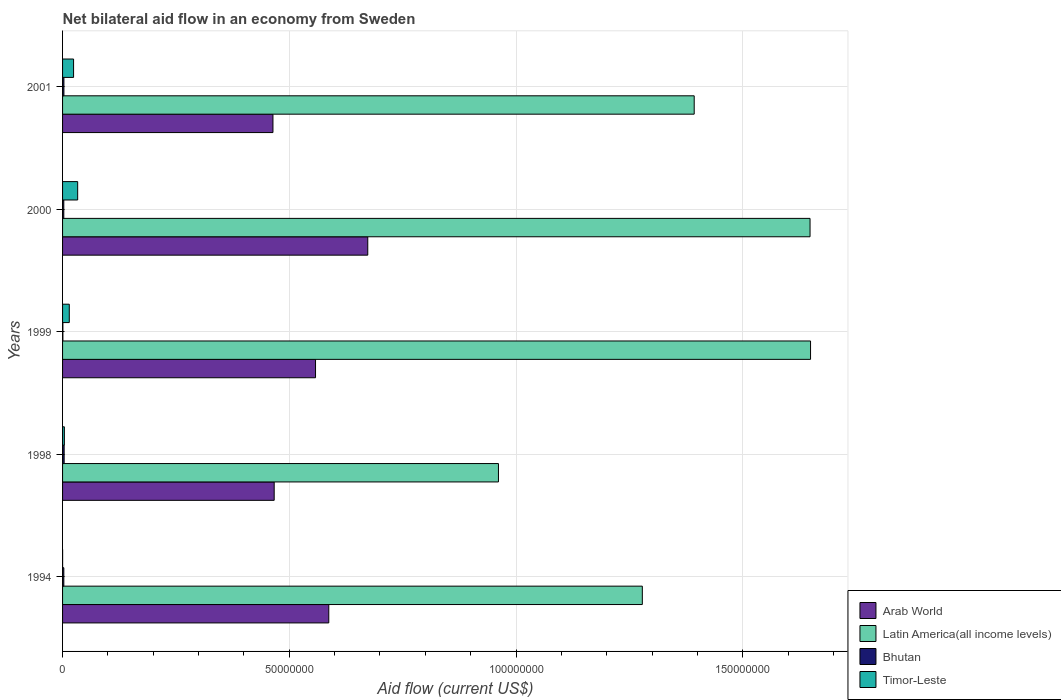How many different coloured bars are there?
Ensure brevity in your answer.  4. Are the number of bars on each tick of the Y-axis equal?
Make the answer very short. Yes. How many bars are there on the 1st tick from the bottom?
Provide a succinct answer. 4. What is the label of the 3rd group of bars from the top?
Your answer should be very brief. 1999. In how many cases, is the number of bars for a given year not equal to the number of legend labels?
Your response must be concise. 0. What is the net bilateral aid flow in Latin America(all income levels) in 1998?
Your response must be concise. 9.61e+07. Across all years, what is the maximum net bilateral aid flow in Latin America(all income levels)?
Ensure brevity in your answer.  1.65e+08. Across all years, what is the minimum net bilateral aid flow in Bhutan?
Offer a terse response. 7.00e+04. What is the total net bilateral aid flow in Timor-Leste in the graph?
Provide a succinct answer. 7.65e+06. What is the difference between the net bilateral aid flow in Bhutan in 1994 and that in 2001?
Provide a short and direct response. -2.00e+04. What is the difference between the net bilateral aid flow in Arab World in 1999 and the net bilateral aid flow in Timor-Leste in 2001?
Provide a succinct answer. 5.34e+07. What is the average net bilateral aid flow in Latin America(all income levels) per year?
Offer a terse response. 1.39e+08. In the year 1999, what is the difference between the net bilateral aid flow in Arab World and net bilateral aid flow in Bhutan?
Keep it short and to the point. 5.57e+07. In how many years, is the net bilateral aid flow in Bhutan greater than 10000000 US$?
Make the answer very short. 0. What is the ratio of the net bilateral aid flow in Latin America(all income levels) in 1994 to that in 1998?
Offer a very short reply. 1.33. Is the net bilateral aid flow in Arab World in 1994 less than that in 2000?
Your answer should be compact. Yes. Is the difference between the net bilateral aid flow in Arab World in 1998 and 2000 greater than the difference between the net bilateral aid flow in Bhutan in 1998 and 2000?
Offer a terse response. No. What is the difference between the highest and the lowest net bilateral aid flow in Latin America(all income levels)?
Ensure brevity in your answer.  6.88e+07. In how many years, is the net bilateral aid flow in Latin America(all income levels) greater than the average net bilateral aid flow in Latin America(all income levels) taken over all years?
Keep it short and to the point. 3. Is the sum of the net bilateral aid flow in Bhutan in 1999 and 2000 greater than the maximum net bilateral aid flow in Arab World across all years?
Provide a succinct answer. No. Is it the case that in every year, the sum of the net bilateral aid flow in Arab World and net bilateral aid flow in Latin America(all income levels) is greater than the sum of net bilateral aid flow in Timor-Leste and net bilateral aid flow in Bhutan?
Give a very brief answer. Yes. What does the 4th bar from the top in 1994 represents?
Offer a terse response. Arab World. What does the 3rd bar from the bottom in 2000 represents?
Provide a short and direct response. Bhutan. Is it the case that in every year, the sum of the net bilateral aid flow in Timor-Leste and net bilateral aid flow in Bhutan is greater than the net bilateral aid flow in Latin America(all income levels)?
Provide a short and direct response. No. How many bars are there?
Provide a short and direct response. 20. What is the difference between two consecutive major ticks on the X-axis?
Give a very brief answer. 5.00e+07. Are the values on the major ticks of X-axis written in scientific E-notation?
Your response must be concise. No. Does the graph contain any zero values?
Give a very brief answer. No. Does the graph contain grids?
Your answer should be very brief. Yes. How many legend labels are there?
Ensure brevity in your answer.  4. What is the title of the graph?
Your answer should be compact. Net bilateral aid flow in an economy from Sweden. Does "Sweden" appear as one of the legend labels in the graph?
Ensure brevity in your answer.  No. What is the label or title of the X-axis?
Provide a succinct answer. Aid flow (current US$). What is the label or title of the Y-axis?
Offer a very short reply. Years. What is the Aid flow (current US$) in Arab World in 1994?
Your answer should be compact. 5.87e+07. What is the Aid flow (current US$) of Latin America(all income levels) in 1994?
Make the answer very short. 1.28e+08. What is the Aid flow (current US$) in Bhutan in 1994?
Your answer should be very brief. 2.80e+05. What is the Aid flow (current US$) in Arab World in 1998?
Offer a very short reply. 4.67e+07. What is the Aid flow (current US$) in Latin America(all income levels) in 1998?
Make the answer very short. 9.61e+07. What is the Aid flow (current US$) in Timor-Leste in 1998?
Give a very brief answer. 4.00e+05. What is the Aid flow (current US$) in Arab World in 1999?
Give a very brief answer. 5.58e+07. What is the Aid flow (current US$) in Latin America(all income levels) in 1999?
Offer a terse response. 1.65e+08. What is the Aid flow (current US$) of Timor-Leste in 1999?
Your answer should be very brief. 1.48e+06. What is the Aid flow (current US$) in Arab World in 2000?
Keep it short and to the point. 6.73e+07. What is the Aid flow (current US$) of Latin America(all income levels) in 2000?
Your response must be concise. 1.65e+08. What is the Aid flow (current US$) in Timor-Leste in 2000?
Ensure brevity in your answer.  3.33e+06. What is the Aid flow (current US$) in Arab World in 2001?
Provide a succinct answer. 4.64e+07. What is the Aid flow (current US$) of Latin America(all income levels) in 2001?
Offer a very short reply. 1.39e+08. What is the Aid flow (current US$) in Timor-Leste in 2001?
Keep it short and to the point. 2.43e+06. Across all years, what is the maximum Aid flow (current US$) of Arab World?
Your answer should be very brief. 6.73e+07. Across all years, what is the maximum Aid flow (current US$) of Latin America(all income levels)?
Your answer should be compact. 1.65e+08. Across all years, what is the maximum Aid flow (current US$) of Timor-Leste?
Offer a very short reply. 3.33e+06. Across all years, what is the minimum Aid flow (current US$) in Arab World?
Make the answer very short. 4.64e+07. Across all years, what is the minimum Aid flow (current US$) in Latin America(all income levels)?
Provide a short and direct response. 9.61e+07. Across all years, what is the minimum Aid flow (current US$) in Timor-Leste?
Offer a terse response. 10000. What is the total Aid flow (current US$) in Arab World in the graph?
Provide a succinct answer. 2.75e+08. What is the total Aid flow (current US$) of Latin America(all income levels) in the graph?
Offer a terse response. 6.93e+08. What is the total Aid flow (current US$) of Bhutan in the graph?
Your answer should be compact. 1.27e+06. What is the total Aid flow (current US$) in Timor-Leste in the graph?
Ensure brevity in your answer.  7.65e+06. What is the difference between the Aid flow (current US$) in Arab World in 1994 and that in 1998?
Provide a succinct answer. 1.20e+07. What is the difference between the Aid flow (current US$) in Latin America(all income levels) in 1994 and that in 1998?
Provide a short and direct response. 3.17e+07. What is the difference between the Aid flow (current US$) in Timor-Leste in 1994 and that in 1998?
Provide a succinct answer. -3.90e+05. What is the difference between the Aid flow (current US$) in Arab World in 1994 and that in 1999?
Provide a short and direct response. 2.92e+06. What is the difference between the Aid flow (current US$) in Latin America(all income levels) in 1994 and that in 1999?
Keep it short and to the point. -3.71e+07. What is the difference between the Aid flow (current US$) in Bhutan in 1994 and that in 1999?
Provide a succinct answer. 2.10e+05. What is the difference between the Aid flow (current US$) of Timor-Leste in 1994 and that in 1999?
Offer a terse response. -1.47e+06. What is the difference between the Aid flow (current US$) in Arab World in 1994 and that in 2000?
Your answer should be compact. -8.60e+06. What is the difference between the Aid flow (current US$) of Latin America(all income levels) in 1994 and that in 2000?
Ensure brevity in your answer.  -3.70e+07. What is the difference between the Aid flow (current US$) of Bhutan in 1994 and that in 2000?
Offer a terse response. 10000. What is the difference between the Aid flow (current US$) in Timor-Leste in 1994 and that in 2000?
Keep it short and to the point. -3.32e+06. What is the difference between the Aid flow (current US$) in Arab World in 1994 and that in 2001?
Your answer should be compact. 1.23e+07. What is the difference between the Aid flow (current US$) in Latin America(all income levels) in 1994 and that in 2001?
Keep it short and to the point. -1.14e+07. What is the difference between the Aid flow (current US$) of Bhutan in 1994 and that in 2001?
Provide a succinct answer. -2.00e+04. What is the difference between the Aid flow (current US$) in Timor-Leste in 1994 and that in 2001?
Make the answer very short. -2.42e+06. What is the difference between the Aid flow (current US$) of Arab World in 1998 and that in 1999?
Ensure brevity in your answer.  -9.12e+06. What is the difference between the Aid flow (current US$) in Latin America(all income levels) in 1998 and that in 1999?
Ensure brevity in your answer.  -6.88e+07. What is the difference between the Aid flow (current US$) in Timor-Leste in 1998 and that in 1999?
Offer a very short reply. -1.08e+06. What is the difference between the Aid flow (current US$) of Arab World in 1998 and that in 2000?
Give a very brief answer. -2.06e+07. What is the difference between the Aid flow (current US$) of Latin America(all income levels) in 1998 and that in 2000?
Keep it short and to the point. -6.87e+07. What is the difference between the Aid flow (current US$) in Timor-Leste in 1998 and that in 2000?
Make the answer very short. -2.93e+06. What is the difference between the Aid flow (current US$) of Latin America(all income levels) in 1998 and that in 2001?
Offer a terse response. -4.32e+07. What is the difference between the Aid flow (current US$) in Timor-Leste in 1998 and that in 2001?
Offer a terse response. -2.03e+06. What is the difference between the Aid flow (current US$) in Arab World in 1999 and that in 2000?
Your response must be concise. -1.15e+07. What is the difference between the Aid flow (current US$) in Timor-Leste in 1999 and that in 2000?
Make the answer very short. -1.85e+06. What is the difference between the Aid flow (current US$) of Arab World in 1999 and that in 2001?
Offer a terse response. 9.39e+06. What is the difference between the Aid flow (current US$) of Latin America(all income levels) in 1999 and that in 2001?
Your response must be concise. 2.57e+07. What is the difference between the Aid flow (current US$) of Bhutan in 1999 and that in 2001?
Ensure brevity in your answer.  -2.30e+05. What is the difference between the Aid flow (current US$) of Timor-Leste in 1999 and that in 2001?
Your answer should be very brief. -9.50e+05. What is the difference between the Aid flow (current US$) in Arab World in 2000 and that in 2001?
Offer a terse response. 2.09e+07. What is the difference between the Aid flow (current US$) of Latin America(all income levels) in 2000 and that in 2001?
Your answer should be compact. 2.56e+07. What is the difference between the Aid flow (current US$) in Timor-Leste in 2000 and that in 2001?
Provide a succinct answer. 9.00e+05. What is the difference between the Aid flow (current US$) of Arab World in 1994 and the Aid flow (current US$) of Latin America(all income levels) in 1998?
Ensure brevity in your answer.  -3.74e+07. What is the difference between the Aid flow (current US$) in Arab World in 1994 and the Aid flow (current US$) in Bhutan in 1998?
Make the answer very short. 5.84e+07. What is the difference between the Aid flow (current US$) in Arab World in 1994 and the Aid flow (current US$) in Timor-Leste in 1998?
Your answer should be very brief. 5.83e+07. What is the difference between the Aid flow (current US$) in Latin America(all income levels) in 1994 and the Aid flow (current US$) in Bhutan in 1998?
Your response must be concise. 1.28e+08. What is the difference between the Aid flow (current US$) of Latin America(all income levels) in 1994 and the Aid flow (current US$) of Timor-Leste in 1998?
Offer a terse response. 1.27e+08. What is the difference between the Aid flow (current US$) of Arab World in 1994 and the Aid flow (current US$) of Latin America(all income levels) in 1999?
Make the answer very short. -1.06e+08. What is the difference between the Aid flow (current US$) in Arab World in 1994 and the Aid flow (current US$) in Bhutan in 1999?
Offer a terse response. 5.86e+07. What is the difference between the Aid flow (current US$) of Arab World in 1994 and the Aid flow (current US$) of Timor-Leste in 1999?
Provide a short and direct response. 5.72e+07. What is the difference between the Aid flow (current US$) in Latin America(all income levels) in 1994 and the Aid flow (current US$) in Bhutan in 1999?
Your answer should be compact. 1.28e+08. What is the difference between the Aid flow (current US$) of Latin America(all income levels) in 1994 and the Aid flow (current US$) of Timor-Leste in 1999?
Offer a terse response. 1.26e+08. What is the difference between the Aid flow (current US$) of Bhutan in 1994 and the Aid flow (current US$) of Timor-Leste in 1999?
Ensure brevity in your answer.  -1.20e+06. What is the difference between the Aid flow (current US$) in Arab World in 1994 and the Aid flow (current US$) in Latin America(all income levels) in 2000?
Offer a terse response. -1.06e+08. What is the difference between the Aid flow (current US$) of Arab World in 1994 and the Aid flow (current US$) of Bhutan in 2000?
Give a very brief answer. 5.84e+07. What is the difference between the Aid flow (current US$) of Arab World in 1994 and the Aid flow (current US$) of Timor-Leste in 2000?
Provide a succinct answer. 5.54e+07. What is the difference between the Aid flow (current US$) in Latin America(all income levels) in 1994 and the Aid flow (current US$) in Bhutan in 2000?
Ensure brevity in your answer.  1.28e+08. What is the difference between the Aid flow (current US$) in Latin America(all income levels) in 1994 and the Aid flow (current US$) in Timor-Leste in 2000?
Provide a short and direct response. 1.25e+08. What is the difference between the Aid flow (current US$) of Bhutan in 1994 and the Aid flow (current US$) of Timor-Leste in 2000?
Keep it short and to the point. -3.05e+06. What is the difference between the Aid flow (current US$) in Arab World in 1994 and the Aid flow (current US$) in Latin America(all income levels) in 2001?
Your response must be concise. -8.06e+07. What is the difference between the Aid flow (current US$) of Arab World in 1994 and the Aid flow (current US$) of Bhutan in 2001?
Give a very brief answer. 5.84e+07. What is the difference between the Aid flow (current US$) in Arab World in 1994 and the Aid flow (current US$) in Timor-Leste in 2001?
Provide a short and direct response. 5.63e+07. What is the difference between the Aid flow (current US$) of Latin America(all income levels) in 1994 and the Aid flow (current US$) of Bhutan in 2001?
Offer a terse response. 1.28e+08. What is the difference between the Aid flow (current US$) in Latin America(all income levels) in 1994 and the Aid flow (current US$) in Timor-Leste in 2001?
Offer a very short reply. 1.25e+08. What is the difference between the Aid flow (current US$) of Bhutan in 1994 and the Aid flow (current US$) of Timor-Leste in 2001?
Provide a short and direct response. -2.15e+06. What is the difference between the Aid flow (current US$) of Arab World in 1998 and the Aid flow (current US$) of Latin America(all income levels) in 1999?
Offer a terse response. -1.18e+08. What is the difference between the Aid flow (current US$) of Arab World in 1998 and the Aid flow (current US$) of Bhutan in 1999?
Your response must be concise. 4.66e+07. What is the difference between the Aid flow (current US$) of Arab World in 1998 and the Aid flow (current US$) of Timor-Leste in 1999?
Your answer should be compact. 4.52e+07. What is the difference between the Aid flow (current US$) of Latin America(all income levels) in 1998 and the Aid flow (current US$) of Bhutan in 1999?
Offer a very short reply. 9.61e+07. What is the difference between the Aid flow (current US$) of Latin America(all income levels) in 1998 and the Aid flow (current US$) of Timor-Leste in 1999?
Keep it short and to the point. 9.46e+07. What is the difference between the Aid flow (current US$) of Bhutan in 1998 and the Aid flow (current US$) of Timor-Leste in 1999?
Offer a terse response. -1.13e+06. What is the difference between the Aid flow (current US$) of Arab World in 1998 and the Aid flow (current US$) of Latin America(all income levels) in 2000?
Give a very brief answer. -1.18e+08. What is the difference between the Aid flow (current US$) of Arab World in 1998 and the Aid flow (current US$) of Bhutan in 2000?
Give a very brief answer. 4.64e+07. What is the difference between the Aid flow (current US$) of Arab World in 1998 and the Aid flow (current US$) of Timor-Leste in 2000?
Your answer should be very brief. 4.33e+07. What is the difference between the Aid flow (current US$) in Latin America(all income levels) in 1998 and the Aid flow (current US$) in Bhutan in 2000?
Offer a terse response. 9.59e+07. What is the difference between the Aid flow (current US$) in Latin America(all income levels) in 1998 and the Aid flow (current US$) in Timor-Leste in 2000?
Offer a very short reply. 9.28e+07. What is the difference between the Aid flow (current US$) in Bhutan in 1998 and the Aid flow (current US$) in Timor-Leste in 2000?
Offer a terse response. -2.98e+06. What is the difference between the Aid flow (current US$) of Arab World in 1998 and the Aid flow (current US$) of Latin America(all income levels) in 2001?
Make the answer very short. -9.26e+07. What is the difference between the Aid flow (current US$) in Arab World in 1998 and the Aid flow (current US$) in Bhutan in 2001?
Give a very brief answer. 4.64e+07. What is the difference between the Aid flow (current US$) in Arab World in 1998 and the Aid flow (current US$) in Timor-Leste in 2001?
Offer a terse response. 4.42e+07. What is the difference between the Aid flow (current US$) of Latin America(all income levels) in 1998 and the Aid flow (current US$) of Bhutan in 2001?
Your response must be concise. 9.58e+07. What is the difference between the Aid flow (current US$) of Latin America(all income levels) in 1998 and the Aid flow (current US$) of Timor-Leste in 2001?
Give a very brief answer. 9.37e+07. What is the difference between the Aid flow (current US$) in Bhutan in 1998 and the Aid flow (current US$) in Timor-Leste in 2001?
Provide a short and direct response. -2.08e+06. What is the difference between the Aid flow (current US$) in Arab World in 1999 and the Aid flow (current US$) in Latin America(all income levels) in 2000?
Give a very brief answer. -1.09e+08. What is the difference between the Aid flow (current US$) in Arab World in 1999 and the Aid flow (current US$) in Bhutan in 2000?
Make the answer very short. 5.55e+07. What is the difference between the Aid flow (current US$) of Arab World in 1999 and the Aid flow (current US$) of Timor-Leste in 2000?
Your answer should be compact. 5.25e+07. What is the difference between the Aid flow (current US$) in Latin America(all income levels) in 1999 and the Aid flow (current US$) in Bhutan in 2000?
Make the answer very short. 1.65e+08. What is the difference between the Aid flow (current US$) of Latin America(all income levels) in 1999 and the Aid flow (current US$) of Timor-Leste in 2000?
Offer a terse response. 1.62e+08. What is the difference between the Aid flow (current US$) of Bhutan in 1999 and the Aid flow (current US$) of Timor-Leste in 2000?
Provide a succinct answer. -3.26e+06. What is the difference between the Aid flow (current US$) in Arab World in 1999 and the Aid flow (current US$) in Latin America(all income levels) in 2001?
Give a very brief answer. -8.35e+07. What is the difference between the Aid flow (current US$) in Arab World in 1999 and the Aid flow (current US$) in Bhutan in 2001?
Ensure brevity in your answer.  5.55e+07. What is the difference between the Aid flow (current US$) of Arab World in 1999 and the Aid flow (current US$) of Timor-Leste in 2001?
Offer a terse response. 5.34e+07. What is the difference between the Aid flow (current US$) of Latin America(all income levels) in 1999 and the Aid flow (current US$) of Bhutan in 2001?
Your answer should be compact. 1.65e+08. What is the difference between the Aid flow (current US$) of Latin America(all income levels) in 1999 and the Aid flow (current US$) of Timor-Leste in 2001?
Provide a short and direct response. 1.63e+08. What is the difference between the Aid flow (current US$) of Bhutan in 1999 and the Aid flow (current US$) of Timor-Leste in 2001?
Give a very brief answer. -2.36e+06. What is the difference between the Aid flow (current US$) of Arab World in 2000 and the Aid flow (current US$) of Latin America(all income levels) in 2001?
Provide a short and direct response. -7.20e+07. What is the difference between the Aid flow (current US$) of Arab World in 2000 and the Aid flow (current US$) of Bhutan in 2001?
Your answer should be very brief. 6.70e+07. What is the difference between the Aid flow (current US$) of Arab World in 2000 and the Aid flow (current US$) of Timor-Leste in 2001?
Provide a short and direct response. 6.49e+07. What is the difference between the Aid flow (current US$) in Latin America(all income levels) in 2000 and the Aid flow (current US$) in Bhutan in 2001?
Offer a terse response. 1.65e+08. What is the difference between the Aid flow (current US$) in Latin America(all income levels) in 2000 and the Aid flow (current US$) in Timor-Leste in 2001?
Give a very brief answer. 1.62e+08. What is the difference between the Aid flow (current US$) in Bhutan in 2000 and the Aid flow (current US$) in Timor-Leste in 2001?
Make the answer very short. -2.16e+06. What is the average Aid flow (current US$) of Arab World per year?
Your answer should be very brief. 5.50e+07. What is the average Aid flow (current US$) in Latin America(all income levels) per year?
Your answer should be compact. 1.39e+08. What is the average Aid flow (current US$) of Bhutan per year?
Give a very brief answer. 2.54e+05. What is the average Aid flow (current US$) in Timor-Leste per year?
Your answer should be very brief. 1.53e+06. In the year 1994, what is the difference between the Aid flow (current US$) of Arab World and Aid flow (current US$) of Latin America(all income levels)?
Keep it short and to the point. -6.92e+07. In the year 1994, what is the difference between the Aid flow (current US$) in Arab World and Aid flow (current US$) in Bhutan?
Offer a terse response. 5.84e+07. In the year 1994, what is the difference between the Aid flow (current US$) of Arab World and Aid flow (current US$) of Timor-Leste?
Provide a short and direct response. 5.87e+07. In the year 1994, what is the difference between the Aid flow (current US$) of Latin America(all income levels) and Aid flow (current US$) of Bhutan?
Your answer should be compact. 1.28e+08. In the year 1994, what is the difference between the Aid flow (current US$) of Latin America(all income levels) and Aid flow (current US$) of Timor-Leste?
Provide a short and direct response. 1.28e+08. In the year 1998, what is the difference between the Aid flow (current US$) in Arab World and Aid flow (current US$) in Latin America(all income levels)?
Provide a succinct answer. -4.95e+07. In the year 1998, what is the difference between the Aid flow (current US$) of Arab World and Aid flow (current US$) of Bhutan?
Offer a very short reply. 4.63e+07. In the year 1998, what is the difference between the Aid flow (current US$) in Arab World and Aid flow (current US$) in Timor-Leste?
Your answer should be very brief. 4.63e+07. In the year 1998, what is the difference between the Aid flow (current US$) in Latin America(all income levels) and Aid flow (current US$) in Bhutan?
Keep it short and to the point. 9.58e+07. In the year 1998, what is the difference between the Aid flow (current US$) in Latin America(all income levels) and Aid flow (current US$) in Timor-Leste?
Provide a succinct answer. 9.57e+07. In the year 1998, what is the difference between the Aid flow (current US$) in Bhutan and Aid flow (current US$) in Timor-Leste?
Provide a short and direct response. -5.00e+04. In the year 1999, what is the difference between the Aid flow (current US$) of Arab World and Aid flow (current US$) of Latin America(all income levels)?
Offer a terse response. -1.09e+08. In the year 1999, what is the difference between the Aid flow (current US$) in Arab World and Aid flow (current US$) in Bhutan?
Ensure brevity in your answer.  5.57e+07. In the year 1999, what is the difference between the Aid flow (current US$) of Arab World and Aid flow (current US$) of Timor-Leste?
Offer a terse response. 5.43e+07. In the year 1999, what is the difference between the Aid flow (current US$) in Latin America(all income levels) and Aid flow (current US$) in Bhutan?
Ensure brevity in your answer.  1.65e+08. In the year 1999, what is the difference between the Aid flow (current US$) of Latin America(all income levels) and Aid flow (current US$) of Timor-Leste?
Your answer should be very brief. 1.63e+08. In the year 1999, what is the difference between the Aid flow (current US$) of Bhutan and Aid flow (current US$) of Timor-Leste?
Your response must be concise. -1.41e+06. In the year 2000, what is the difference between the Aid flow (current US$) in Arab World and Aid flow (current US$) in Latin America(all income levels)?
Offer a very short reply. -9.75e+07. In the year 2000, what is the difference between the Aid flow (current US$) in Arab World and Aid flow (current US$) in Bhutan?
Make the answer very short. 6.70e+07. In the year 2000, what is the difference between the Aid flow (current US$) of Arab World and Aid flow (current US$) of Timor-Leste?
Your answer should be compact. 6.40e+07. In the year 2000, what is the difference between the Aid flow (current US$) in Latin America(all income levels) and Aid flow (current US$) in Bhutan?
Your answer should be compact. 1.65e+08. In the year 2000, what is the difference between the Aid flow (current US$) in Latin America(all income levels) and Aid flow (current US$) in Timor-Leste?
Your answer should be very brief. 1.62e+08. In the year 2000, what is the difference between the Aid flow (current US$) of Bhutan and Aid flow (current US$) of Timor-Leste?
Your answer should be very brief. -3.06e+06. In the year 2001, what is the difference between the Aid flow (current US$) of Arab World and Aid flow (current US$) of Latin America(all income levels)?
Your answer should be compact. -9.29e+07. In the year 2001, what is the difference between the Aid flow (current US$) of Arab World and Aid flow (current US$) of Bhutan?
Provide a succinct answer. 4.61e+07. In the year 2001, what is the difference between the Aid flow (current US$) of Arab World and Aid flow (current US$) of Timor-Leste?
Give a very brief answer. 4.40e+07. In the year 2001, what is the difference between the Aid flow (current US$) of Latin America(all income levels) and Aid flow (current US$) of Bhutan?
Your answer should be compact. 1.39e+08. In the year 2001, what is the difference between the Aid flow (current US$) in Latin America(all income levels) and Aid flow (current US$) in Timor-Leste?
Give a very brief answer. 1.37e+08. In the year 2001, what is the difference between the Aid flow (current US$) in Bhutan and Aid flow (current US$) in Timor-Leste?
Offer a very short reply. -2.13e+06. What is the ratio of the Aid flow (current US$) in Arab World in 1994 to that in 1998?
Your answer should be very brief. 1.26. What is the ratio of the Aid flow (current US$) of Latin America(all income levels) in 1994 to that in 1998?
Your answer should be compact. 1.33. What is the ratio of the Aid flow (current US$) in Timor-Leste in 1994 to that in 1998?
Offer a very short reply. 0.03. What is the ratio of the Aid flow (current US$) in Arab World in 1994 to that in 1999?
Give a very brief answer. 1.05. What is the ratio of the Aid flow (current US$) of Latin America(all income levels) in 1994 to that in 1999?
Ensure brevity in your answer.  0.78. What is the ratio of the Aid flow (current US$) of Bhutan in 1994 to that in 1999?
Your response must be concise. 4. What is the ratio of the Aid flow (current US$) in Timor-Leste in 1994 to that in 1999?
Make the answer very short. 0.01. What is the ratio of the Aid flow (current US$) of Arab World in 1994 to that in 2000?
Make the answer very short. 0.87. What is the ratio of the Aid flow (current US$) in Latin America(all income levels) in 1994 to that in 2000?
Your answer should be very brief. 0.78. What is the ratio of the Aid flow (current US$) in Timor-Leste in 1994 to that in 2000?
Your answer should be compact. 0. What is the ratio of the Aid flow (current US$) of Arab World in 1994 to that in 2001?
Your answer should be compact. 1.27. What is the ratio of the Aid flow (current US$) in Latin America(all income levels) in 1994 to that in 2001?
Provide a succinct answer. 0.92. What is the ratio of the Aid flow (current US$) in Bhutan in 1994 to that in 2001?
Keep it short and to the point. 0.93. What is the ratio of the Aid flow (current US$) in Timor-Leste in 1994 to that in 2001?
Offer a terse response. 0. What is the ratio of the Aid flow (current US$) of Arab World in 1998 to that in 1999?
Keep it short and to the point. 0.84. What is the ratio of the Aid flow (current US$) of Latin America(all income levels) in 1998 to that in 1999?
Keep it short and to the point. 0.58. What is the ratio of the Aid flow (current US$) of Timor-Leste in 1998 to that in 1999?
Keep it short and to the point. 0.27. What is the ratio of the Aid flow (current US$) of Arab World in 1998 to that in 2000?
Offer a very short reply. 0.69. What is the ratio of the Aid flow (current US$) in Latin America(all income levels) in 1998 to that in 2000?
Offer a very short reply. 0.58. What is the ratio of the Aid flow (current US$) in Bhutan in 1998 to that in 2000?
Your answer should be very brief. 1.3. What is the ratio of the Aid flow (current US$) in Timor-Leste in 1998 to that in 2000?
Make the answer very short. 0.12. What is the ratio of the Aid flow (current US$) of Latin America(all income levels) in 1998 to that in 2001?
Your response must be concise. 0.69. What is the ratio of the Aid flow (current US$) in Bhutan in 1998 to that in 2001?
Provide a succinct answer. 1.17. What is the ratio of the Aid flow (current US$) in Timor-Leste in 1998 to that in 2001?
Your answer should be very brief. 0.16. What is the ratio of the Aid flow (current US$) in Arab World in 1999 to that in 2000?
Offer a terse response. 0.83. What is the ratio of the Aid flow (current US$) of Latin America(all income levels) in 1999 to that in 2000?
Your answer should be compact. 1. What is the ratio of the Aid flow (current US$) of Bhutan in 1999 to that in 2000?
Offer a terse response. 0.26. What is the ratio of the Aid flow (current US$) of Timor-Leste in 1999 to that in 2000?
Make the answer very short. 0.44. What is the ratio of the Aid flow (current US$) in Arab World in 1999 to that in 2001?
Give a very brief answer. 1.2. What is the ratio of the Aid flow (current US$) in Latin America(all income levels) in 1999 to that in 2001?
Keep it short and to the point. 1.18. What is the ratio of the Aid flow (current US$) of Bhutan in 1999 to that in 2001?
Make the answer very short. 0.23. What is the ratio of the Aid flow (current US$) in Timor-Leste in 1999 to that in 2001?
Keep it short and to the point. 0.61. What is the ratio of the Aid flow (current US$) in Arab World in 2000 to that in 2001?
Offer a very short reply. 1.45. What is the ratio of the Aid flow (current US$) of Latin America(all income levels) in 2000 to that in 2001?
Make the answer very short. 1.18. What is the ratio of the Aid flow (current US$) of Timor-Leste in 2000 to that in 2001?
Offer a terse response. 1.37. What is the difference between the highest and the second highest Aid flow (current US$) of Arab World?
Provide a short and direct response. 8.60e+06. What is the difference between the highest and the second highest Aid flow (current US$) of Timor-Leste?
Provide a short and direct response. 9.00e+05. What is the difference between the highest and the lowest Aid flow (current US$) of Arab World?
Your answer should be very brief. 2.09e+07. What is the difference between the highest and the lowest Aid flow (current US$) of Latin America(all income levels)?
Give a very brief answer. 6.88e+07. What is the difference between the highest and the lowest Aid flow (current US$) of Bhutan?
Make the answer very short. 2.80e+05. What is the difference between the highest and the lowest Aid flow (current US$) of Timor-Leste?
Your answer should be compact. 3.32e+06. 